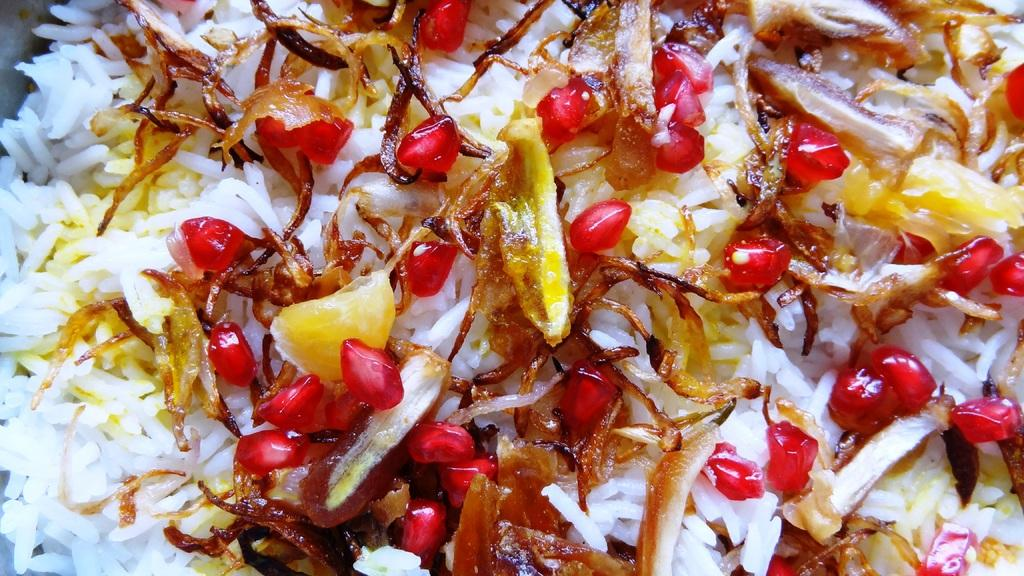What type of food is visible in the image? There is rice in the image. What is added to the rice to enhance its flavor? Fried onions are present on the rice. What additional ingredient can be seen on the rice? Pomegranate seeds are on the rice. What type of industry can be seen near the river in the image? There is no industry or river present in the image; it only features rice with fried onions and pomegranate seeds. How many cents are visible on the rice in the image? There are no cents present on the rice in the image. 